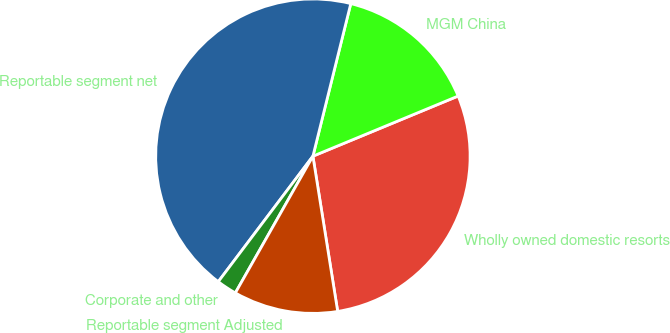<chart> <loc_0><loc_0><loc_500><loc_500><pie_chart><fcel>Wholly owned domestic resorts<fcel>MGM China<fcel>Reportable segment net<fcel>Corporate and other<fcel>Reportable segment Adjusted<nl><fcel>28.73%<fcel>14.88%<fcel>43.59%<fcel>2.07%<fcel>10.73%<nl></chart> 